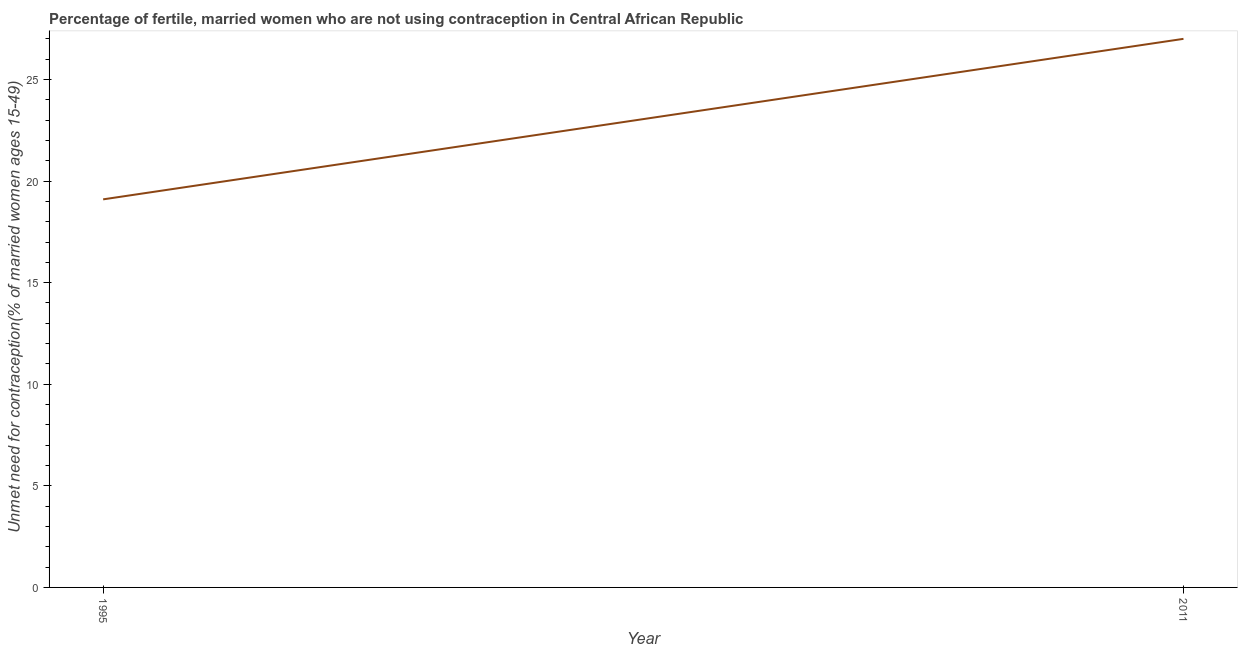What is the number of married women who are not using contraception in 2011?
Provide a succinct answer. 27. Across all years, what is the minimum number of married women who are not using contraception?
Give a very brief answer. 19.1. In which year was the number of married women who are not using contraception maximum?
Provide a short and direct response. 2011. In which year was the number of married women who are not using contraception minimum?
Your answer should be compact. 1995. What is the sum of the number of married women who are not using contraception?
Keep it short and to the point. 46.1. What is the difference between the number of married women who are not using contraception in 1995 and 2011?
Your answer should be very brief. -7.9. What is the average number of married women who are not using contraception per year?
Your answer should be very brief. 23.05. What is the median number of married women who are not using contraception?
Your answer should be compact. 23.05. What is the ratio of the number of married women who are not using contraception in 1995 to that in 2011?
Offer a terse response. 0.71. Is the number of married women who are not using contraception in 1995 less than that in 2011?
Provide a succinct answer. Yes. Are the values on the major ticks of Y-axis written in scientific E-notation?
Give a very brief answer. No. Does the graph contain grids?
Your answer should be very brief. No. What is the title of the graph?
Keep it short and to the point. Percentage of fertile, married women who are not using contraception in Central African Republic. What is the label or title of the Y-axis?
Your response must be concise.  Unmet need for contraception(% of married women ages 15-49). What is the  Unmet need for contraception(% of married women ages 15-49) in 2011?
Provide a succinct answer. 27. What is the difference between the  Unmet need for contraception(% of married women ages 15-49) in 1995 and 2011?
Ensure brevity in your answer.  -7.9. What is the ratio of the  Unmet need for contraception(% of married women ages 15-49) in 1995 to that in 2011?
Your response must be concise. 0.71. 